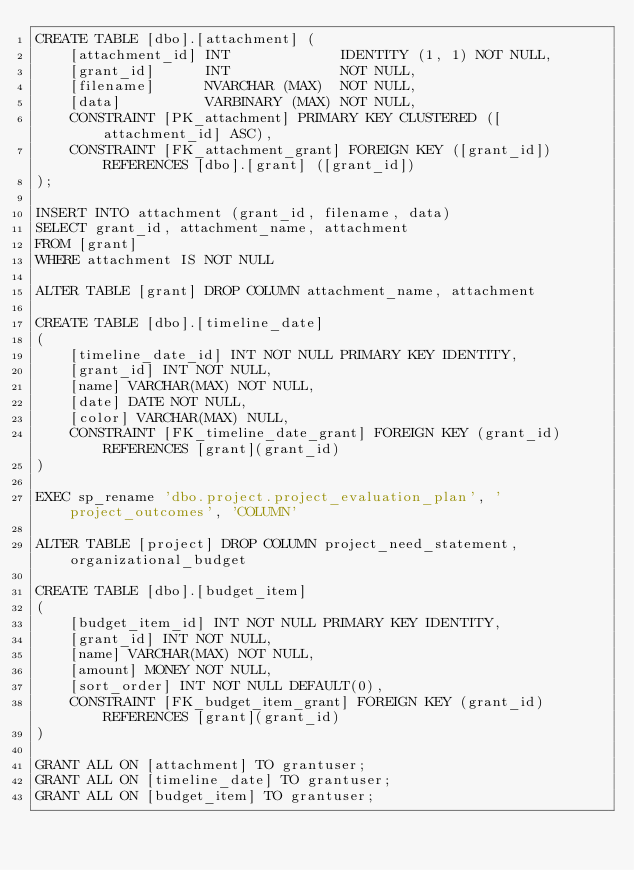<code> <loc_0><loc_0><loc_500><loc_500><_SQL_>CREATE TABLE [dbo].[attachment] (
    [attachment_id] INT             IDENTITY (1, 1) NOT NULL,
    [grant_id]      INT             NOT NULL,
    [filename]      NVARCHAR (MAX)  NOT NULL,
    [data]          VARBINARY (MAX) NOT NULL,
    CONSTRAINT [PK_attachment] PRIMARY KEY CLUSTERED ([attachment_id] ASC),
    CONSTRAINT [FK_attachment_grant] FOREIGN KEY ([grant_id]) REFERENCES [dbo].[grant] ([grant_id])
);

INSERT INTO attachment (grant_id, filename, data)
SELECT grant_id, attachment_name, attachment
FROM [grant]
WHERE attachment IS NOT NULL

ALTER TABLE [grant] DROP COLUMN attachment_name, attachment

CREATE TABLE [dbo].[timeline_date]
(
	[timeline_date_id] INT NOT NULL PRIMARY KEY IDENTITY, 
    [grant_id] INT NOT NULL, 
    [name] VARCHAR(MAX) NOT NULL, 
    [date] DATE NOT NULL, 
    [color] VARCHAR(MAX) NULL, 
    CONSTRAINT [FK_timeline_date_grant] FOREIGN KEY (grant_id) REFERENCES [grant](grant_id)
)

EXEC sp_rename 'dbo.project.project_evaluation_plan', 'project_outcomes', 'COLUMN'

ALTER TABLE [project] DROP COLUMN project_need_statement, organizational_budget

CREATE TABLE [dbo].[budget_item]
(
	[budget_item_id] INT NOT NULL PRIMARY KEY IDENTITY, 
    [grant_id] INT NOT NULL, 
    [name] VARCHAR(MAX) NOT NULL, 
    [amount] MONEY NOT NULL,
	[sort_order] INT NOT NULL DEFAULT(0),
    CONSTRAINT [FK_budget_item_grant] FOREIGN KEY (grant_id) REFERENCES [grant](grant_id)
)

GRANT ALL ON [attachment] TO grantuser;
GRANT ALL ON [timeline_date] TO grantuser;
GRANT ALL ON [budget_item] TO grantuser;
</code> 